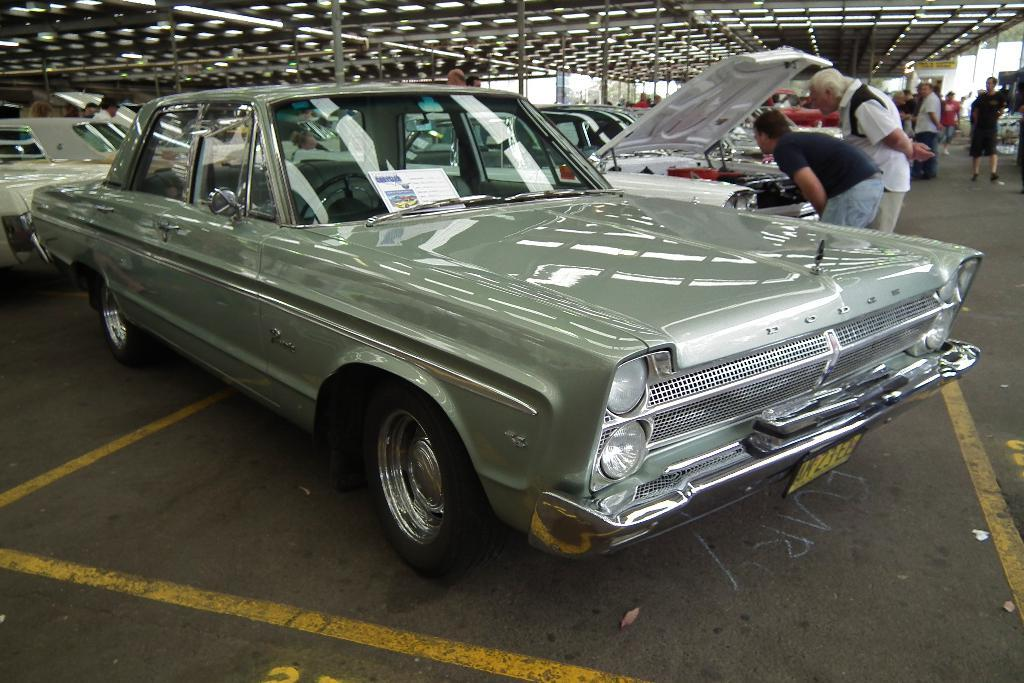What types of objects can be seen in the image? There are vehicles in the image. Are there any living beings present in the image? Yes, there are people in the image. Where are the vehicles and people located? The vehicles and people are on the ground. What can be seen in the background of the image? There is a roof and lights visible in the background of the image. How many slaves are visible in the image? There is no mention of slaves in the image, as it features vehicles and people on the ground. 